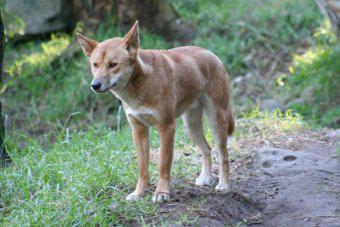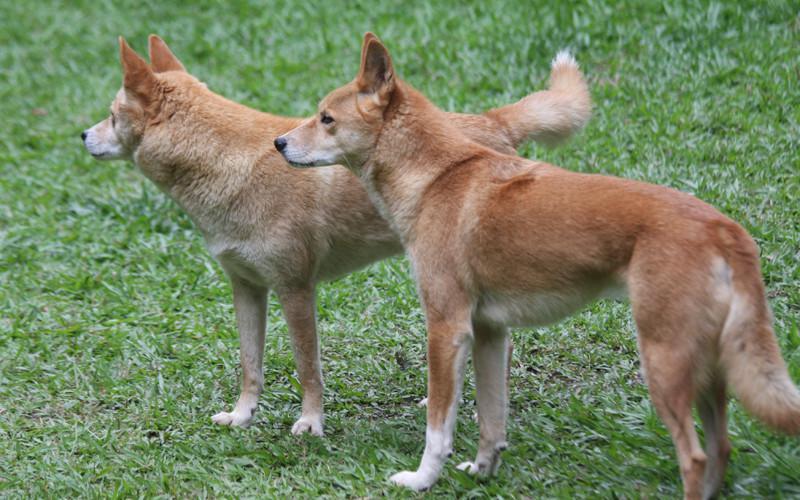The first image is the image on the left, the second image is the image on the right. Analyze the images presented: Is the assertion "All dogs in the images are standing with all visible paws on the ground." valid? Answer yes or no. Yes. 